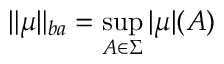Convert formula to latex. <formula><loc_0><loc_0><loc_500><loc_500>\| \mu \| _ { b a } = \sup _ { A \in \Sigma } | \mu | ( A )</formula> 